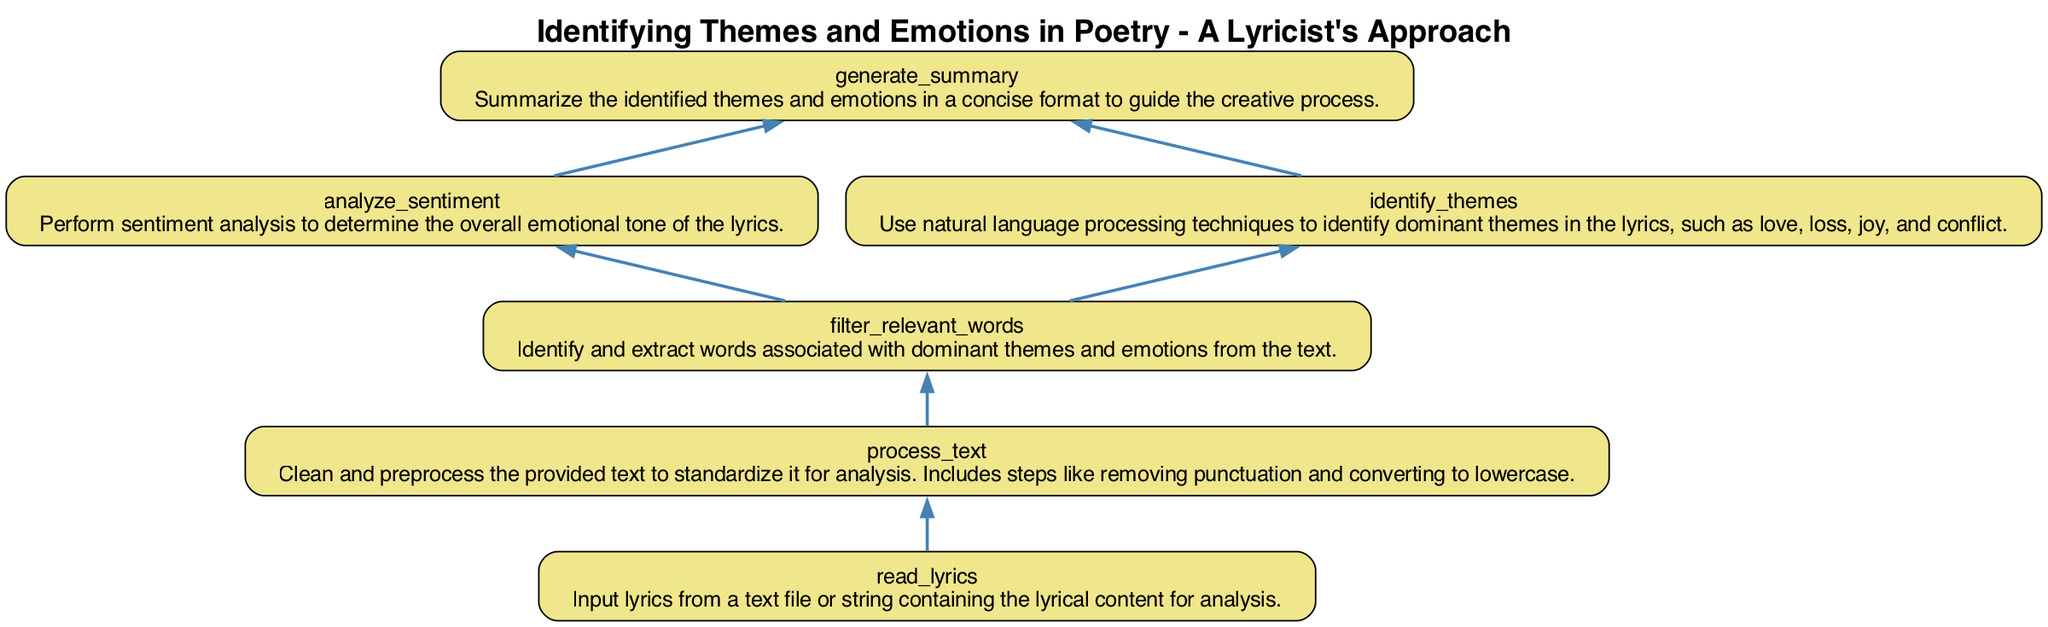What is the first step in the process? The diagram shows that the first step is "read_lyrics," which involves inputting the lyrics for analysis. This node has no dependencies, indicating it starts the flow of the process.
Answer: read_lyrics How many words are associated with themes and emotions? The "filter_relevant_words" node is responsible for identifying and extracting words associated with themes and emotions. It is dependent on "process_text," which must first be completed.
Answer: Not specified What node follows the "process_text" step? Following "process_text," the next node is "filter_relevant_words." This indicates that once the text is processed, the relevant words are then filtered for analysis.
Answer: filter_relevant_words Which nodes contribute to generating the summary? The nodes "analyze_sentiment" and "identify_themes" both feed into "generate_summary." This means that both sentiment analysis and theme identification are considered in the summary creation.
Answer: analyze_sentiment, identify_themes How many total nodes are present in the diagram? By counting all described steps in the flowchart, there are a total of six nodes: "read_lyrics," "process_text," "filter_relevant_words," "analyze_sentiment," "identify_themes," and "generate_summary."
Answer: Six What are the dependencies of the "analyze_sentiment" node? The "analyze_sentiment" node has one dependency: it relies on "filter_relevant_words" to perform sentiment analysis, indicating that relevant words must be identified first.
Answer: filter_relevant_words What is the main purpose of the "identify_themes" node? The main purpose of "identify_themes" is to utilize natural language processing techniques to determine dominant themes within the lyrics, such as love or conflict. This focuses on thematic analysis based on filtered words.
Answer: Identify themes in lyrics What step provides input for the entire analysis? The step that serves as input for the entire analysis process is "read_lyrics." It starts the flow by supplying the lyrical content that will be processed.
Answer: read_lyrics Which node has no dependencies? The "read_lyrics" node is unique as it has no dependencies, meaning it is the entry point for the analysis process and does not require prior steps to be completed.
Answer: read_lyrics 